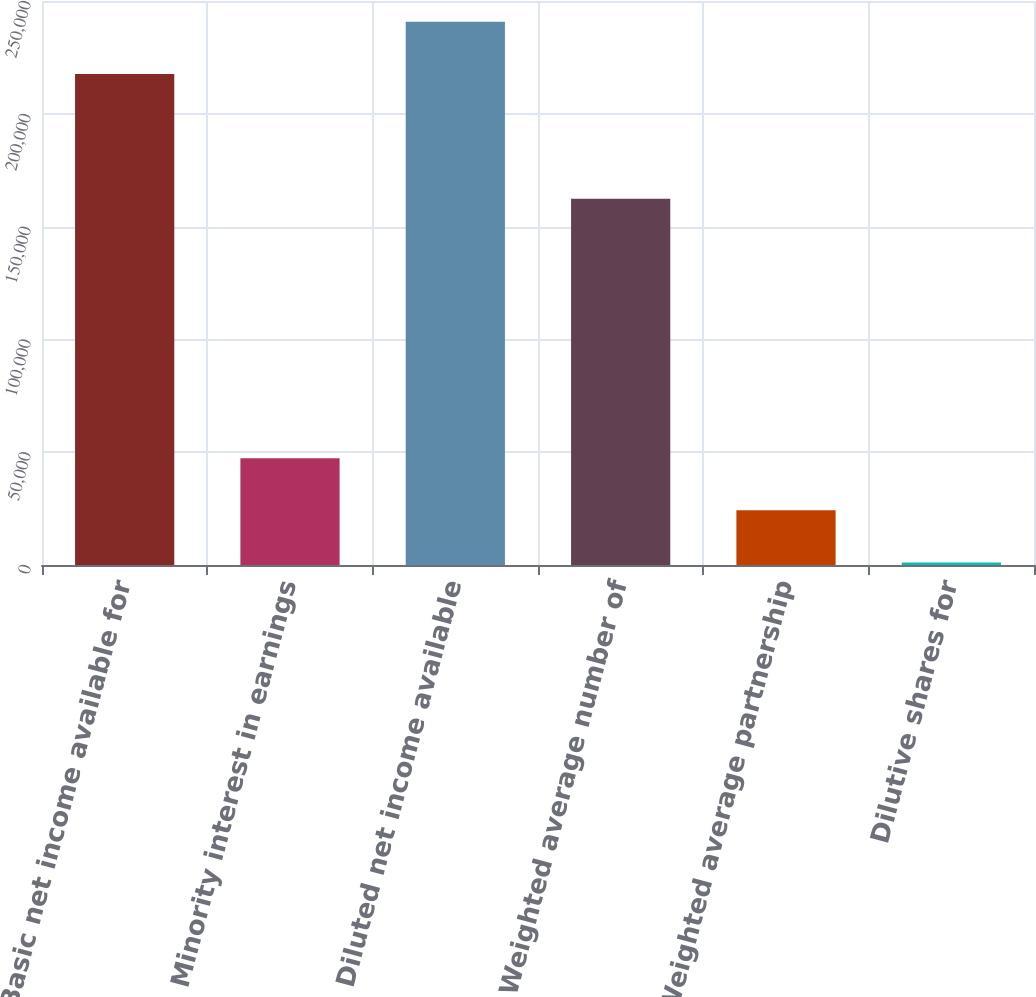Convert chart to OTSL. <chart><loc_0><loc_0><loc_500><loc_500><bar_chart><fcel>Basic net income available for<fcel>Minority interest in earnings<fcel>Diluted net income available<fcel>Weighted average number of<fcel>Weighted average partnership<fcel>Dilutive shares for<nl><fcel>217692<fcel>47342.2<fcel>240786<fcel>162349<fcel>24248.6<fcel>1155<nl></chart> 